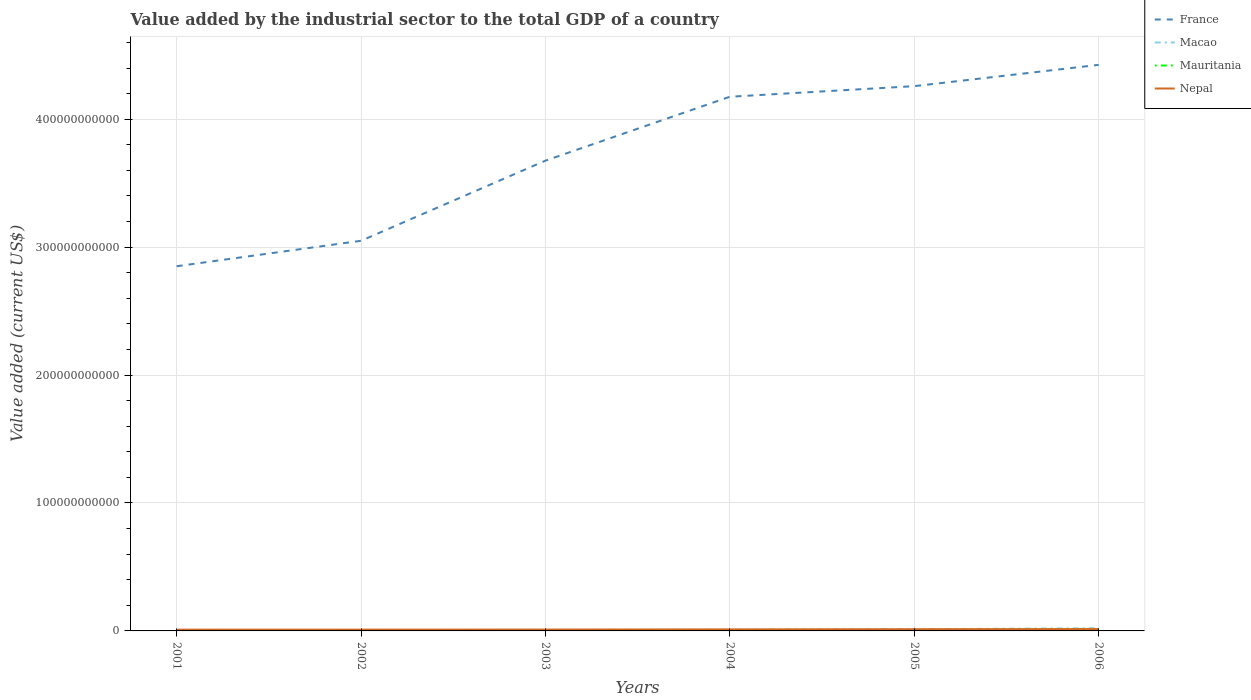Does the line corresponding to France intersect with the line corresponding to Mauritania?
Ensure brevity in your answer.  No. Is the number of lines equal to the number of legend labels?
Offer a very short reply. Yes. Across all years, what is the maximum value added by the industrial sector to the total GDP in Macao?
Provide a short and direct response. 6.62e+08. What is the total value added by the industrial sector to the total GDP in Nepal in the graph?
Offer a terse response. -2.41e+08. What is the difference between the highest and the second highest value added by the industrial sector to the total GDP in Nepal?
Ensure brevity in your answer.  4.52e+08. What is the difference between the highest and the lowest value added by the industrial sector to the total GDP in Macao?
Offer a very short reply. 2. What is the difference between two consecutive major ticks on the Y-axis?
Your answer should be compact. 1.00e+11. How many legend labels are there?
Ensure brevity in your answer.  4. How are the legend labels stacked?
Ensure brevity in your answer.  Vertical. What is the title of the graph?
Offer a terse response. Value added by the industrial sector to the total GDP of a country. Does "Malaysia" appear as one of the legend labels in the graph?
Your answer should be compact. No. What is the label or title of the X-axis?
Give a very brief answer. Years. What is the label or title of the Y-axis?
Offer a very short reply. Value added (current US$). What is the Value added (current US$) of France in 2001?
Your answer should be very brief. 2.85e+11. What is the Value added (current US$) of Macao in 2001?
Provide a short and direct response. 6.62e+08. What is the Value added (current US$) of Mauritania in 2001?
Your response must be concise. 3.44e+08. What is the Value added (current US$) in Nepal in 2001?
Provide a succinct answer. 1.00e+09. What is the Value added (current US$) of France in 2002?
Offer a very short reply. 3.05e+11. What is the Value added (current US$) of Macao in 2002?
Give a very brief answer. 6.69e+08. What is the Value added (current US$) of Mauritania in 2002?
Make the answer very short. 3.25e+08. What is the Value added (current US$) of Nepal in 2002?
Ensure brevity in your answer.  1.03e+09. What is the Value added (current US$) in France in 2003?
Provide a succinct answer. 3.68e+11. What is the Value added (current US$) in Macao in 2003?
Provide a short and direct response. 7.75e+08. What is the Value added (current US$) in Mauritania in 2003?
Your answer should be compact. 3.52e+08. What is the Value added (current US$) of Nepal in 2003?
Your answer should be very brief. 1.07e+09. What is the Value added (current US$) in France in 2004?
Your answer should be compact. 4.18e+11. What is the Value added (current US$) of Macao in 2004?
Give a very brief answer. 8.80e+08. What is the Value added (current US$) of Mauritania in 2004?
Provide a short and direct response. 4.60e+08. What is the Value added (current US$) in Nepal in 2004?
Your answer should be very brief. 1.21e+09. What is the Value added (current US$) of France in 2005?
Provide a succinct answer. 4.26e+11. What is the Value added (current US$) in Macao in 2005?
Ensure brevity in your answer.  1.32e+09. What is the Value added (current US$) of Mauritania in 2005?
Provide a succinct answer. 6.69e+08. What is the Value added (current US$) in Nepal in 2005?
Give a very brief answer. 1.34e+09. What is the Value added (current US$) in France in 2006?
Offer a terse response. 4.42e+11. What is the Value added (current US$) in Macao in 2006?
Provide a succinct answer. 2.09e+09. What is the Value added (current US$) in Mauritania in 2006?
Offer a very short reply. 1.32e+09. What is the Value added (current US$) in Nepal in 2006?
Your answer should be compact. 1.45e+09. Across all years, what is the maximum Value added (current US$) of France?
Ensure brevity in your answer.  4.42e+11. Across all years, what is the maximum Value added (current US$) in Macao?
Provide a short and direct response. 2.09e+09. Across all years, what is the maximum Value added (current US$) of Mauritania?
Make the answer very short. 1.32e+09. Across all years, what is the maximum Value added (current US$) in Nepal?
Your answer should be compact. 1.45e+09. Across all years, what is the minimum Value added (current US$) of France?
Ensure brevity in your answer.  2.85e+11. Across all years, what is the minimum Value added (current US$) in Macao?
Make the answer very short. 6.62e+08. Across all years, what is the minimum Value added (current US$) in Mauritania?
Make the answer very short. 3.25e+08. Across all years, what is the minimum Value added (current US$) in Nepal?
Offer a terse response. 1.00e+09. What is the total Value added (current US$) of France in the graph?
Provide a short and direct response. 2.24e+12. What is the total Value added (current US$) in Macao in the graph?
Ensure brevity in your answer.  6.40e+09. What is the total Value added (current US$) of Mauritania in the graph?
Ensure brevity in your answer.  3.47e+09. What is the total Value added (current US$) of Nepal in the graph?
Provide a short and direct response. 7.10e+09. What is the difference between the Value added (current US$) of France in 2001 and that in 2002?
Provide a short and direct response. -1.99e+1. What is the difference between the Value added (current US$) of Macao in 2001 and that in 2002?
Your answer should be very brief. -6.62e+06. What is the difference between the Value added (current US$) in Mauritania in 2001 and that in 2002?
Give a very brief answer. 1.96e+07. What is the difference between the Value added (current US$) of Nepal in 2001 and that in 2002?
Make the answer very short. -2.46e+07. What is the difference between the Value added (current US$) of France in 2001 and that in 2003?
Provide a succinct answer. -8.25e+1. What is the difference between the Value added (current US$) of Macao in 2001 and that in 2003?
Ensure brevity in your answer.  -1.13e+08. What is the difference between the Value added (current US$) of Mauritania in 2001 and that in 2003?
Offer a terse response. -7.99e+06. What is the difference between the Value added (current US$) of Nepal in 2001 and that in 2003?
Your answer should be very brief. -7.35e+07. What is the difference between the Value added (current US$) of France in 2001 and that in 2004?
Your answer should be compact. -1.32e+11. What is the difference between the Value added (current US$) of Macao in 2001 and that in 2004?
Offer a terse response. -2.18e+08. What is the difference between the Value added (current US$) of Mauritania in 2001 and that in 2004?
Offer a terse response. -1.16e+08. What is the difference between the Value added (current US$) of Nepal in 2001 and that in 2004?
Your response must be concise. -2.11e+08. What is the difference between the Value added (current US$) in France in 2001 and that in 2005?
Make the answer very short. -1.41e+11. What is the difference between the Value added (current US$) in Macao in 2001 and that in 2005?
Make the answer very short. -6.61e+08. What is the difference between the Value added (current US$) of Mauritania in 2001 and that in 2005?
Give a very brief answer. -3.25e+08. What is the difference between the Value added (current US$) in Nepal in 2001 and that in 2005?
Offer a very short reply. -3.38e+08. What is the difference between the Value added (current US$) of France in 2001 and that in 2006?
Your answer should be compact. -1.57e+11. What is the difference between the Value added (current US$) in Macao in 2001 and that in 2006?
Provide a short and direct response. -1.43e+09. What is the difference between the Value added (current US$) in Mauritania in 2001 and that in 2006?
Give a very brief answer. -9.77e+08. What is the difference between the Value added (current US$) of Nepal in 2001 and that in 2006?
Keep it short and to the point. -4.52e+08. What is the difference between the Value added (current US$) of France in 2002 and that in 2003?
Offer a very short reply. -6.26e+1. What is the difference between the Value added (current US$) in Macao in 2002 and that in 2003?
Give a very brief answer. -1.06e+08. What is the difference between the Value added (current US$) in Mauritania in 2002 and that in 2003?
Offer a terse response. -2.76e+07. What is the difference between the Value added (current US$) in Nepal in 2002 and that in 2003?
Your answer should be very brief. -4.89e+07. What is the difference between the Value added (current US$) of France in 2002 and that in 2004?
Give a very brief answer. -1.13e+11. What is the difference between the Value added (current US$) in Macao in 2002 and that in 2004?
Your answer should be very brief. -2.12e+08. What is the difference between the Value added (current US$) in Mauritania in 2002 and that in 2004?
Make the answer very short. -1.35e+08. What is the difference between the Value added (current US$) of Nepal in 2002 and that in 2004?
Your response must be concise. -1.86e+08. What is the difference between the Value added (current US$) in France in 2002 and that in 2005?
Your answer should be compact. -1.21e+11. What is the difference between the Value added (current US$) in Macao in 2002 and that in 2005?
Offer a terse response. -6.54e+08. What is the difference between the Value added (current US$) in Mauritania in 2002 and that in 2005?
Offer a very short reply. -3.45e+08. What is the difference between the Value added (current US$) in Nepal in 2002 and that in 2005?
Your answer should be compact. -3.13e+08. What is the difference between the Value added (current US$) of France in 2002 and that in 2006?
Provide a short and direct response. -1.38e+11. What is the difference between the Value added (current US$) in Macao in 2002 and that in 2006?
Make the answer very short. -1.42e+09. What is the difference between the Value added (current US$) of Mauritania in 2002 and that in 2006?
Your response must be concise. -9.97e+08. What is the difference between the Value added (current US$) in Nepal in 2002 and that in 2006?
Offer a very short reply. -4.28e+08. What is the difference between the Value added (current US$) in France in 2003 and that in 2004?
Offer a very short reply. -5.00e+1. What is the difference between the Value added (current US$) in Macao in 2003 and that in 2004?
Your response must be concise. -1.05e+08. What is the difference between the Value added (current US$) of Mauritania in 2003 and that in 2004?
Ensure brevity in your answer.  -1.08e+08. What is the difference between the Value added (current US$) of Nepal in 2003 and that in 2004?
Offer a very short reply. -1.37e+08. What is the difference between the Value added (current US$) of France in 2003 and that in 2005?
Your answer should be very brief. -5.82e+1. What is the difference between the Value added (current US$) of Macao in 2003 and that in 2005?
Offer a terse response. -5.48e+08. What is the difference between the Value added (current US$) of Mauritania in 2003 and that in 2005?
Your answer should be compact. -3.17e+08. What is the difference between the Value added (current US$) of Nepal in 2003 and that in 2005?
Your response must be concise. -2.64e+08. What is the difference between the Value added (current US$) of France in 2003 and that in 2006?
Make the answer very short. -7.49e+1. What is the difference between the Value added (current US$) in Macao in 2003 and that in 2006?
Offer a terse response. -1.32e+09. What is the difference between the Value added (current US$) of Mauritania in 2003 and that in 2006?
Offer a very short reply. -9.69e+08. What is the difference between the Value added (current US$) of Nepal in 2003 and that in 2006?
Provide a short and direct response. -3.79e+08. What is the difference between the Value added (current US$) in France in 2004 and that in 2005?
Offer a terse response. -8.28e+09. What is the difference between the Value added (current US$) in Macao in 2004 and that in 2005?
Offer a very short reply. -4.43e+08. What is the difference between the Value added (current US$) of Mauritania in 2004 and that in 2005?
Keep it short and to the point. -2.09e+08. What is the difference between the Value added (current US$) in Nepal in 2004 and that in 2005?
Provide a short and direct response. -1.27e+08. What is the difference between the Value added (current US$) of France in 2004 and that in 2006?
Make the answer very short. -2.49e+1. What is the difference between the Value added (current US$) in Macao in 2004 and that in 2006?
Your answer should be compact. -1.21e+09. What is the difference between the Value added (current US$) in Mauritania in 2004 and that in 2006?
Offer a terse response. -8.61e+08. What is the difference between the Value added (current US$) of Nepal in 2004 and that in 2006?
Offer a terse response. -2.41e+08. What is the difference between the Value added (current US$) in France in 2005 and that in 2006?
Offer a terse response. -1.66e+1. What is the difference between the Value added (current US$) of Macao in 2005 and that in 2006?
Offer a very short reply. -7.70e+08. What is the difference between the Value added (current US$) in Mauritania in 2005 and that in 2006?
Provide a short and direct response. -6.52e+08. What is the difference between the Value added (current US$) of Nepal in 2005 and that in 2006?
Provide a short and direct response. -1.14e+08. What is the difference between the Value added (current US$) of France in 2001 and the Value added (current US$) of Macao in 2002?
Your answer should be compact. 2.84e+11. What is the difference between the Value added (current US$) of France in 2001 and the Value added (current US$) of Mauritania in 2002?
Provide a succinct answer. 2.85e+11. What is the difference between the Value added (current US$) of France in 2001 and the Value added (current US$) of Nepal in 2002?
Make the answer very short. 2.84e+11. What is the difference between the Value added (current US$) of Macao in 2001 and the Value added (current US$) of Mauritania in 2002?
Offer a terse response. 3.37e+08. What is the difference between the Value added (current US$) of Macao in 2001 and the Value added (current US$) of Nepal in 2002?
Your response must be concise. -3.63e+08. What is the difference between the Value added (current US$) of Mauritania in 2001 and the Value added (current US$) of Nepal in 2002?
Provide a short and direct response. -6.81e+08. What is the difference between the Value added (current US$) of France in 2001 and the Value added (current US$) of Macao in 2003?
Offer a terse response. 2.84e+11. What is the difference between the Value added (current US$) of France in 2001 and the Value added (current US$) of Mauritania in 2003?
Make the answer very short. 2.85e+11. What is the difference between the Value added (current US$) of France in 2001 and the Value added (current US$) of Nepal in 2003?
Offer a terse response. 2.84e+11. What is the difference between the Value added (current US$) in Macao in 2001 and the Value added (current US$) in Mauritania in 2003?
Keep it short and to the point. 3.10e+08. What is the difference between the Value added (current US$) in Macao in 2001 and the Value added (current US$) in Nepal in 2003?
Provide a short and direct response. -4.12e+08. What is the difference between the Value added (current US$) of Mauritania in 2001 and the Value added (current US$) of Nepal in 2003?
Give a very brief answer. -7.30e+08. What is the difference between the Value added (current US$) of France in 2001 and the Value added (current US$) of Macao in 2004?
Your answer should be compact. 2.84e+11. What is the difference between the Value added (current US$) of France in 2001 and the Value added (current US$) of Mauritania in 2004?
Ensure brevity in your answer.  2.85e+11. What is the difference between the Value added (current US$) in France in 2001 and the Value added (current US$) in Nepal in 2004?
Provide a succinct answer. 2.84e+11. What is the difference between the Value added (current US$) of Macao in 2001 and the Value added (current US$) of Mauritania in 2004?
Make the answer very short. 2.02e+08. What is the difference between the Value added (current US$) in Macao in 2001 and the Value added (current US$) in Nepal in 2004?
Provide a succinct answer. -5.50e+08. What is the difference between the Value added (current US$) in Mauritania in 2001 and the Value added (current US$) in Nepal in 2004?
Provide a succinct answer. -8.67e+08. What is the difference between the Value added (current US$) of France in 2001 and the Value added (current US$) of Macao in 2005?
Make the answer very short. 2.84e+11. What is the difference between the Value added (current US$) in France in 2001 and the Value added (current US$) in Mauritania in 2005?
Ensure brevity in your answer.  2.84e+11. What is the difference between the Value added (current US$) of France in 2001 and the Value added (current US$) of Nepal in 2005?
Give a very brief answer. 2.84e+11. What is the difference between the Value added (current US$) in Macao in 2001 and the Value added (current US$) in Mauritania in 2005?
Keep it short and to the point. -7.19e+06. What is the difference between the Value added (current US$) in Macao in 2001 and the Value added (current US$) in Nepal in 2005?
Your answer should be very brief. -6.77e+08. What is the difference between the Value added (current US$) of Mauritania in 2001 and the Value added (current US$) of Nepal in 2005?
Provide a succinct answer. -9.95e+08. What is the difference between the Value added (current US$) in France in 2001 and the Value added (current US$) in Macao in 2006?
Offer a terse response. 2.83e+11. What is the difference between the Value added (current US$) of France in 2001 and the Value added (current US$) of Mauritania in 2006?
Ensure brevity in your answer.  2.84e+11. What is the difference between the Value added (current US$) of France in 2001 and the Value added (current US$) of Nepal in 2006?
Keep it short and to the point. 2.84e+11. What is the difference between the Value added (current US$) in Macao in 2001 and the Value added (current US$) in Mauritania in 2006?
Offer a terse response. -6.59e+08. What is the difference between the Value added (current US$) of Macao in 2001 and the Value added (current US$) of Nepal in 2006?
Your response must be concise. -7.91e+08. What is the difference between the Value added (current US$) of Mauritania in 2001 and the Value added (current US$) of Nepal in 2006?
Your answer should be compact. -1.11e+09. What is the difference between the Value added (current US$) in France in 2002 and the Value added (current US$) in Macao in 2003?
Provide a short and direct response. 3.04e+11. What is the difference between the Value added (current US$) of France in 2002 and the Value added (current US$) of Mauritania in 2003?
Your answer should be very brief. 3.05e+11. What is the difference between the Value added (current US$) of France in 2002 and the Value added (current US$) of Nepal in 2003?
Keep it short and to the point. 3.04e+11. What is the difference between the Value added (current US$) in Macao in 2002 and the Value added (current US$) in Mauritania in 2003?
Your answer should be very brief. 3.16e+08. What is the difference between the Value added (current US$) in Macao in 2002 and the Value added (current US$) in Nepal in 2003?
Give a very brief answer. -4.06e+08. What is the difference between the Value added (current US$) of Mauritania in 2002 and the Value added (current US$) of Nepal in 2003?
Provide a succinct answer. -7.50e+08. What is the difference between the Value added (current US$) in France in 2002 and the Value added (current US$) in Macao in 2004?
Provide a succinct answer. 3.04e+11. What is the difference between the Value added (current US$) of France in 2002 and the Value added (current US$) of Mauritania in 2004?
Provide a short and direct response. 3.04e+11. What is the difference between the Value added (current US$) in France in 2002 and the Value added (current US$) in Nepal in 2004?
Provide a short and direct response. 3.04e+11. What is the difference between the Value added (current US$) in Macao in 2002 and the Value added (current US$) in Mauritania in 2004?
Make the answer very short. 2.09e+08. What is the difference between the Value added (current US$) of Macao in 2002 and the Value added (current US$) of Nepal in 2004?
Your answer should be very brief. -5.43e+08. What is the difference between the Value added (current US$) of Mauritania in 2002 and the Value added (current US$) of Nepal in 2004?
Your answer should be compact. -8.87e+08. What is the difference between the Value added (current US$) of France in 2002 and the Value added (current US$) of Macao in 2005?
Provide a short and direct response. 3.04e+11. What is the difference between the Value added (current US$) in France in 2002 and the Value added (current US$) in Mauritania in 2005?
Your answer should be compact. 3.04e+11. What is the difference between the Value added (current US$) in France in 2002 and the Value added (current US$) in Nepal in 2005?
Your answer should be very brief. 3.04e+11. What is the difference between the Value added (current US$) of Macao in 2002 and the Value added (current US$) of Mauritania in 2005?
Your answer should be very brief. -5.71e+05. What is the difference between the Value added (current US$) of Macao in 2002 and the Value added (current US$) of Nepal in 2005?
Your response must be concise. -6.70e+08. What is the difference between the Value added (current US$) of Mauritania in 2002 and the Value added (current US$) of Nepal in 2005?
Ensure brevity in your answer.  -1.01e+09. What is the difference between the Value added (current US$) of France in 2002 and the Value added (current US$) of Macao in 2006?
Provide a succinct answer. 3.03e+11. What is the difference between the Value added (current US$) of France in 2002 and the Value added (current US$) of Mauritania in 2006?
Offer a terse response. 3.04e+11. What is the difference between the Value added (current US$) in France in 2002 and the Value added (current US$) in Nepal in 2006?
Your response must be concise. 3.03e+11. What is the difference between the Value added (current US$) in Macao in 2002 and the Value added (current US$) in Mauritania in 2006?
Your answer should be very brief. -6.53e+08. What is the difference between the Value added (current US$) in Macao in 2002 and the Value added (current US$) in Nepal in 2006?
Your answer should be very brief. -7.84e+08. What is the difference between the Value added (current US$) of Mauritania in 2002 and the Value added (current US$) of Nepal in 2006?
Offer a very short reply. -1.13e+09. What is the difference between the Value added (current US$) of France in 2003 and the Value added (current US$) of Macao in 2004?
Keep it short and to the point. 3.67e+11. What is the difference between the Value added (current US$) in France in 2003 and the Value added (current US$) in Mauritania in 2004?
Offer a terse response. 3.67e+11. What is the difference between the Value added (current US$) in France in 2003 and the Value added (current US$) in Nepal in 2004?
Offer a very short reply. 3.66e+11. What is the difference between the Value added (current US$) of Macao in 2003 and the Value added (current US$) of Mauritania in 2004?
Give a very brief answer. 3.15e+08. What is the difference between the Value added (current US$) of Macao in 2003 and the Value added (current US$) of Nepal in 2004?
Keep it short and to the point. -4.37e+08. What is the difference between the Value added (current US$) of Mauritania in 2003 and the Value added (current US$) of Nepal in 2004?
Your answer should be very brief. -8.59e+08. What is the difference between the Value added (current US$) in France in 2003 and the Value added (current US$) in Macao in 2005?
Provide a succinct answer. 3.66e+11. What is the difference between the Value added (current US$) in France in 2003 and the Value added (current US$) in Mauritania in 2005?
Ensure brevity in your answer.  3.67e+11. What is the difference between the Value added (current US$) of France in 2003 and the Value added (current US$) of Nepal in 2005?
Ensure brevity in your answer.  3.66e+11. What is the difference between the Value added (current US$) of Macao in 2003 and the Value added (current US$) of Mauritania in 2005?
Ensure brevity in your answer.  1.06e+08. What is the difference between the Value added (current US$) of Macao in 2003 and the Value added (current US$) of Nepal in 2005?
Your answer should be very brief. -5.64e+08. What is the difference between the Value added (current US$) of Mauritania in 2003 and the Value added (current US$) of Nepal in 2005?
Your response must be concise. -9.87e+08. What is the difference between the Value added (current US$) in France in 2003 and the Value added (current US$) in Macao in 2006?
Give a very brief answer. 3.65e+11. What is the difference between the Value added (current US$) in France in 2003 and the Value added (current US$) in Mauritania in 2006?
Your answer should be very brief. 3.66e+11. What is the difference between the Value added (current US$) of France in 2003 and the Value added (current US$) of Nepal in 2006?
Your answer should be compact. 3.66e+11. What is the difference between the Value added (current US$) of Macao in 2003 and the Value added (current US$) of Mauritania in 2006?
Provide a succinct answer. -5.46e+08. What is the difference between the Value added (current US$) of Macao in 2003 and the Value added (current US$) of Nepal in 2006?
Offer a very short reply. -6.78e+08. What is the difference between the Value added (current US$) of Mauritania in 2003 and the Value added (current US$) of Nepal in 2006?
Give a very brief answer. -1.10e+09. What is the difference between the Value added (current US$) of France in 2004 and the Value added (current US$) of Macao in 2005?
Ensure brevity in your answer.  4.16e+11. What is the difference between the Value added (current US$) in France in 2004 and the Value added (current US$) in Mauritania in 2005?
Keep it short and to the point. 4.17e+11. What is the difference between the Value added (current US$) of France in 2004 and the Value added (current US$) of Nepal in 2005?
Provide a succinct answer. 4.16e+11. What is the difference between the Value added (current US$) in Macao in 2004 and the Value added (current US$) in Mauritania in 2005?
Your response must be concise. 2.11e+08. What is the difference between the Value added (current US$) in Macao in 2004 and the Value added (current US$) in Nepal in 2005?
Your answer should be very brief. -4.58e+08. What is the difference between the Value added (current US$) in Mauritania in 2004 and the Value added (current US$) in Nepal in 2005?
Ensure brevity in your answer.  -8.79e+08. What is the difference between the Value added (current US$) of France in 2004 and the Value added (current US$) of Macao in 2006?
Provide a short and direct response. 4.15e+11. What is the difference between the Value added (current US$) in France in 2004 and the Value added (current US$) in Mauritania in 2006?
Keep it short and to the point. 4.16e+11. What is the difference between the Value added (current US$) of France in 2004 and the Value added (current US$) of Nepal in 2006?
Provide a succinct answer. 4.16e+11. What is the difference between the Value added (current US$) of Macao in 2004 and the Value added (current US$) of Mauritania in 2006?
Provide a succinct answer. -4.41e+08. What is the difference between the Value added (current US$) of Macao in 2004 and the Value added (current US$) of Nepal in 2006?
Give a very brief answer. -5.73e+08. What is the difference between the Value added (current US$) of Mauritania in 2004 and the Value added (current US$) of Nepal in 2006?
Ensure brevity in your answer.  -9.93e+08. What is the difference between the Value added (current US$) in France in 2005 and the Value added (current US$) in Macao in 2006?
Your answer should be compact. 4.24e+11. What is the difference between the Value added (current US$) of France in 2005 and the Value added (current US$) of Mauritania in 2006?
Make the answer very short. 4.25e+11. What is the difference between the Value added (current US$) in France in 2005 and the Value added (current US$) in Nepal in 2006?
Provide a short and direct response. 4.24e+11. What is the difference between the Value added (current US$) of Macao in 2005 and the Value added (current US$) of Mauritania in 2006?
Keep it short and to the point. 1.77e+06. What is the difference between the Value added (current US$) in Macao in 2005 and the Value added (current US$) in Nepal in 2006?
Offer a very short reply. -1.30e+08. What is the difference between the Value added (current US$) of Mauritania in 2005 and the Value added (current US$) of Nepal in 2006?
Provide a succinct answer. -7.84e+08. What is the average Value added (current US$) in France per year?
Keep it short and to the point. 3.74e+11. What is the average Value added (current US$) in Macao per year?
Provide a short and direct response. 1.07e+09. What is the average Value added (current US$) in Mauritania per year?
Provide a short and direct response. 5.79e+08. What is the average Value added (current US$) of Nepal per year?
Your answer should be very brief. 1.18e+09. In the year 2001, what is the difference between the Value added (current US$) of France and Value added (current US$) of Macao?
Ensure brevity in your answer.  2.84e+11. In the year 2001, what is the difference between the Value added (current US$) of France and Value added (current US$) of Mauritania?
Offer a very short reply. 2.85e+11. In the year 2001, what is the difference between the Value added (current US$) in France and Value added (current US$) in Nepal?
Ensure brevity in your answer.  2.84e+11. In the year 2001, what is the difference between the Value added (current US$) of Macao and Value added (current US$) of Mauritania?
Provide a short and direct response. 3.18e+08. In the year 2001, what is the difference between the Value added (current US$) of Macao and Value added (current US$) of Nepal?
Your answer should be compact. -3.39e+08. In the year 2001, what is the difference between the Value added (current US$) of Mauritania and Value added (current US$) of Nepal?
Keep it short and to the point. -6.57e+08. In the year 2002, what is the difference between the Value added (current US$) of France and Value added (current US$) of Macao?
Ensure brevity in your answer.  3.04e+11. In the year 2002, what is the difference between the Value added (current US$) in France and Value added (current US$) in Mauritania?
Your answer should be compact. 3.05e+11. In the year 2002, what is the difference between the Value added (current US$) in France and Value added (current US$) in Nepal?
Your response must be concise. 3.04e+11. In the year 2002, what is the difference between the Value added (current US$) of Macao and Value added (current US$) of Mauritania?
Make the answer very short. 3.44e+08. In the year 2002, what is the difference between the Value added (current US$) of Macao and Value added (current US$) of Nepal?
Your answer should be very brief. -3.57e+08. In the year 2002, what is the difference between the Value added (current US$) of Mauritania and Value added (current US$) of Nepal?
Your answer should be very brief. -7.01e+08. In the year 2003, what is the difference between the Value added (current US$) of France and Value added (current US$) of Macao?
Your response must be concise. 3.67e+11. In the year 2003, what is the difference between the Value added (current US$) in France and Value added (current US$) in Mauritania?
Ensure brevity in your answer.  3.67e+11. In the year 2003, what is the difference between the Value added (current US$) in France and Value added (current US$) in Nepal?
Provide a short and direct response. 3.67e+11. In the year 2003, what is the difference between the Value added (current US$) in Macao and Value added (current US$) in Mauritania?
Provide a succinct answer. 4.23e+08. In the year 2003, what is the difference between the Value added (current US$) of Macao and Value added (current US$) of Nepal?
Give a very brief answer. -2.99e+08. In the year 2003, what is the difference between the Value added (current US$) in Mauritania and Value added (current US$) in Nepal?
Keep it short and to the point. -7.22e+08. In the year 2004, what is the difference between the Value added (current US$) of France and Value added (current US$) of Macao?
Your answer should be compact. 4.17e+11. In the year 2004, what is the difference between the Value added (current US$) of France and Value added (current US$) of Mauritania?
Your answer should be compact. 4.17e+11. In the year 2004, what is the difference between the Value added (current US$) of France and Value added (current US$) of Nepal?
Give a very brief answer. 4.16e+11. In the year 2004, what is the difference between the Value added (current US$) of Macao and Value added (current US$) of Mauritania?
Your answer should be compact. 4.20e+08. In the year 2004, what is the difference between the Value added (current US$) of Macao and Value added (current US$) of Nepal?
Provide a short and direct response. -3.31e+08. In the year 2004, what is the difference between the Value added (current US$) of Mauritania and Value added (current US$) of Nepal?
Ensure brevity in your answer.  -7.52e+08. In the year 2005, what is the difference between the Value added (current US$) in France and Value added (current US$) in Macao?
Offer a terse response. 4.25e+11. In the year 2005, what is the difference between the Value added (current US$) of France and Value added (current US$) of Mauritania?
Give a very brief answer. 4.25e+11. In the year 2005, what is the difference between the Value added (current US$) of France and Value added (current US$) of Nepal?
Provide a succinct answer. 4.24e+11. In the year 2005, what is the difference between the Value added (current US$) in Macao and Value added (current US$) in Mauritania?
Your answer should be compact. 6.54e+08. In the year 2005, what is the difference between the Value added (current US$) of Macao and Value added (current US$) of Nepal?
Make the answer very short. -1.59e+07. In the year 2005, what is the difference between the Value added (current US$) of Mauritania and Value added (current US$) of Nepal?
Your answer should be compact. -6.70e+08. In the year 2006, what is the difference between the Value added (current US$) of France and Value added (current US$) of Macao?
Your response must be concise. 4.40e+11. In the year 2006, what is the difference between the Value added (current US$) in France and Value added (current US$) in Mauritania?
Give a very brief answer. 4.41e+11. In the year 2006, what is the difference between the Value added (current US$) of France and Value added (current US$) of Nepal?
Your answer should be compact. 4.41e+11. In the year 2006, what is the difference between the Value added (current US$) in Macao and Value added (current US$) in Mauritania?
Give a very brief answer. 7.71e+08. In the year 2006, what is the difference between the Value added (current US$) in Macao and Value added (current US$) in Nepal?
Ensure brevity in your answer.  6.39e+08. In the year 2006, what is the difference between the Value added (current US$) in Mauritania and Value added (current US$) in Nepal?
Provide a succinct answer. -1.32e+08. What is the ratio of the Value added (current US$) in France in 2001 to that in 2002?
Your answer should be very brief. 0.93. What is the ratio of the Value added (current US$) of Macao in 2001 to that in 2002?
Ensure brevity in your answer.  0.99. What is the ratio of the Value added (current US$) in Mauritania in 2001 to that in 2002?
Give a very brief answer. 1.06. What is the ratio of the Value added (current US$) in Nepal in 2001 to that in 2002?
Provide a short and direct response. 0.98. What is the ratio of the Value added (current US$) of France in 2001 to that in 2003?
Ensure brevity in your answer.  0.78. What is the ratio of the Value added (current US$) in Macao in 2001 to that in 2003?
Give a very brief answer. 0.85. What is the ratio of the Value added (current US$) in Mauritania in 2001 to that in 2003?
Your response must be concise. 0.98. What is the ratio of the Value added (current US$) in Nepal in 2001 to that in 2003?
Provide a short and direct response. 0.93. What is the ratio of the Value added (current US$) in France in 2001 to that in 2004?
Ensure brevity in your answer.  0.68. What is the ratio of the Value added (current US$) of Macao in 2001 to that in 2004?
Your response must be concise. 0.75. What is the ratio of the Value added (current US$) in Mauritania in 2001 to that in 2004?
Ensure brevity in your answer.  0.75. What is the ratio of the Value added (current US$) of Nepal in 2001 to that in 2004?
Your answer should be very brief. 0.83. What is the ratio of the Value added (current US$) in France in 2001 to that in 2005?
Offer a terse response. 0.67. What is the ratio of the Value added (current US$) of Macao in 2001 to that in 2005?
Keep it short and to the point. 0.5. What is the ratio of the Value added (current US$) of Mauritania in 2001 to that in 2005?
Your response must be concise. 0.51. What is the ratio of the Value added (current US$) of Nepal in 2001 to that in 2005?
Your answer should be compact. 0.75. What is the ratio of the Value added (current US$) in France in 2001 to that in 2006?
Your answer should be compact. 0.64. What is the ratio of the Value added (current US$) of Macao in 2001 to that in 2006?
Your answer should be compact. 0.32. What is the ratio of the Value added (current US$) of Mauritania in 2001 to that in 2006?
Your answer should be compact. 0.26. What is the ratio of the Value added (current US$) in Nepal in 2001 to that in 2006?
Your response must be concise. 0.69. What is the ratio of the Value added (current US$) of France in 2002 to that in 2003?
Offer a very short reply. 0.83. What is the ratio of the Value added (current US$) in Macao in 2002 to that in 2003?
Make the answer very short. 0.86. What is the ratio of the Value added (current US$) in Mauritania in 2002 to that in 2003?
Provide a succinct answer. 0.92. What is the ratio of the Value added (current US$) of Nepal in 2002 to that in 2003?
Ensure brevity in your answer.  0.95. What is the ratio of the Value added (current US$) in France in 2002 to that in 2004?
Your answer should be compact. 0.73. What is the ratio of the Value added (current US$) of Macao in 2002 to that in 2004?
Provide a succinct answer. 0.76. What is the ratio of the Value added (current US$) of Mauritania in 2002 to that in 2004?
Offer a terse response. 0.71. What is the ratio of the Value added (current US$) in Nepal in 2002 to that in 2004?
Keep it short and to the point. 0.85. What is the ratio of the Value added (current US$) of France in 2002 to that in 2005?
Offer a very short reply. 0.72. What is the ratio of the Value added (current US$) of Macao in 2002 to that in 2005?
Give a very brief answer. 0.51. What is the ratio of the Value added (current US$) in Mauritania in 2002 to that in 2005?
Ensure brevity in your answer.  0.49. What is the ratio of the Value added (current US$) in Nepal in 2002 to that in 2005?
Provide a short and direct response. 0.77. What is the ratio of the Value added (current US$) of France in 2002 to that in 2006?
Your response must be concise. 0.69. What is the ratio of the Value added (current US$) in Macao in 2002 to that in 2006?
Your answer should be very brief. 0.32. What is the ratio of the Value added (current US$) of Mauritania in 2002 to that in 2006?
Your answer should be very brief. 0.25. What is the ratio of the Value added (current US$) in Nepal in 2002 to that in 2006?
Keep it short and to the point. 0.71. What is the ratio of the Value added (current US$) in France in 2003 to that in 2004?
Provide a short and direct response. 0.88. What is the ratio of the Value added (current US$) of Macao in 2003 to that in 2004?
Your response must be concise. 0.88. What is the ratio of the Value added (current US$) in Mauritania in 2003 to that in 2004?
Offer a terse response. 0.77. What is the ratio of the Value added (current US$) of Nepal in 2003 to that in 2004?
Your response must be concise. 0.89. What is the ratio of the Value added (current US$) in France in 2003 to that in 2005?
Make the answer very short. 0.86. What is the ratio of the Value added (current US$) in Macao in 2003 to that in 2005?
Provide a short and direct response. 0.59. What is the ratio of the Value added (current US$) of Mauritania in 2003 to that in 2005?
Keep it short and to the point. 0.53. What is the ratio of the Value added (current US$) of Nepal in 2003 to that in 2005?
Make the answer very short. 0.8. What is the ratio of the Value added (current US$) of France in 2003 to that in 2006?
Offer a terse response. 0.83. What is the ratio of the Value added (current US$) in Macao in 2003 to that in 2006?
Provide a short and direct response. 0.37. What is the ratio of the Value added (current US$) in Mauritania in 2003 to that in 2006?
Provide a short and direct response. 0.27. What is the ratio of the Value added (current US$) in Nepal in 2003 to that in 2006?
Your answer should be very brief. 0.74. What is the ratio of the Value added (current US$) of France in 2004 to that in 2005?
Provide a short and direct response. 0.98. What is the ratio of the Value added (current US$) of Macao in 2004 to that in 2005?
Your answer should be compact. 0.67. What is the ratio of the Value added (current US$) in Mauritania in 2004 to that in 2005?
Offer a very short reply. 0.69. What is the ratio of the Value added (current US$) in Nepal in 2004 to that in 2005?
Offer a terse response. 0.91. What is the ratio of the Value added (current US$) of France in 2004 to that in 2006?
Provide a succinct answer. 0.94. What is the ratio of the Value added (current US$) of Macao in 2004 to that in 2006?
Provide a succinct answer. 0.42. What is the ratio of the Value added (current US$) in Mauritania in 2004 to that in 2006?
Offer a terse response. 0.35. What is the ratio of the Value added (current US$) in Nepal in 2004 to that in 2006?
Offer a very short reply. 0.83. What is the ratio of the Value added (current US$) in France in 2005 to that in 2006?
Your response must be concise. 0.96. What is the ratio of the Value added (current US$) of Macao in 2005 to that in 2006?
Your answer should be very brief. 0.63. What is the ratio of the Value added (current US$) in Mauritania in 2005 to that in 2006?
Keep it short and to the point. 0.51. What is the ratio of the Value added (current US$) in Nepal in 2005 to that in 2006?
Offer a terse response. 0.92. What is the difference between the highest and the second highest Value added (current US$) of France?
Make the answer very short. 1.66e+1. What is the difference between the highest and the second highest Value added (current US$) in Macao?
Provide a short and direct response. 7.70e+08. What is the difference between the highest and the second highest Value added (current US$) of Mauritania?
Your answer should be compact. 6.52e+08. What is the difference between the highest and the second highest Value added (current US$) in Nepal?
Your answer should be compact. 1.14e+08. What is the difference between the highest and the lowest Value added (current US$) of France?
Your answer should be compact. 1.57e+11. What is the difference between the highest and the lowest Value added (current US$) in Macao?
Offer a terse response. 1.43e+09. What is the difference between the highest and the lowest Value added (current US$) in Mauritania?
Offer a terse response. 9.97e+08. What is the difference between the highest and the lowest Value added (current US$) in Nepal?
Your answer should be compact. 4.52e+08. 